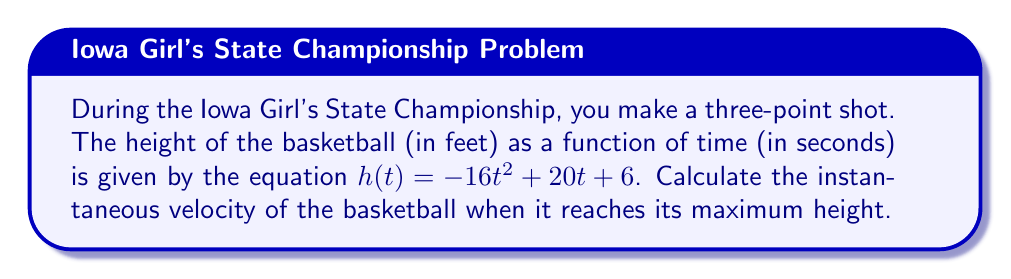Can you answer this question? To solve this problem, we'll follow these steps:

1) First, we need to find when the basketball reaches its maximum height. This occurs when the velocity is zero.

2) The velocity function $v(t)$ is the derivative of the height function $h(t)$:

   $v(t) = h'(t) = -32t + 20$

3) Set $v(t) = 0$ and solve for $t$:

   $-32t + 20 = 0$
   $-32t = -20$
   $t = \frac{5}{8} = 0.625$ seconds

4) Now that we know when the ball reaches its maximum height, we need to find the instantaneous velocity immediately after this point.

5) To do this, we'll calculate the derivative of the velocity function, which gives us the acceleration:

   $a(t) = v'(t) = -32$

6) The acceleration is constant at -32 ft/s², which is the acceleration due to gravity.

7) At the maximum height, the velocity is zero, but immediately after, it starts falling. The instantaneous velocity at this point is the limit of the velocity as time approaches $\frac{5}{8}$ from the right.

8) Given that acceleration is constant, we can use the equation:

   $v = v_0 + at$

   Where $v_0 = 0$ (velocity at max height), $a = -32$, and $t$ approaches 0.

9) As $t$ approaches 0, $v$ approaches 0.

Therefore, the instantaneous velocity at the maximum height is 0 ft/s, but it immediately begins to change at a rate of -32 ft/s².
Answer: $0$ ft/s 